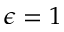<formula> <loc_0><loc_0><loc_500><loc_500>\epsilon = 1</formula> 